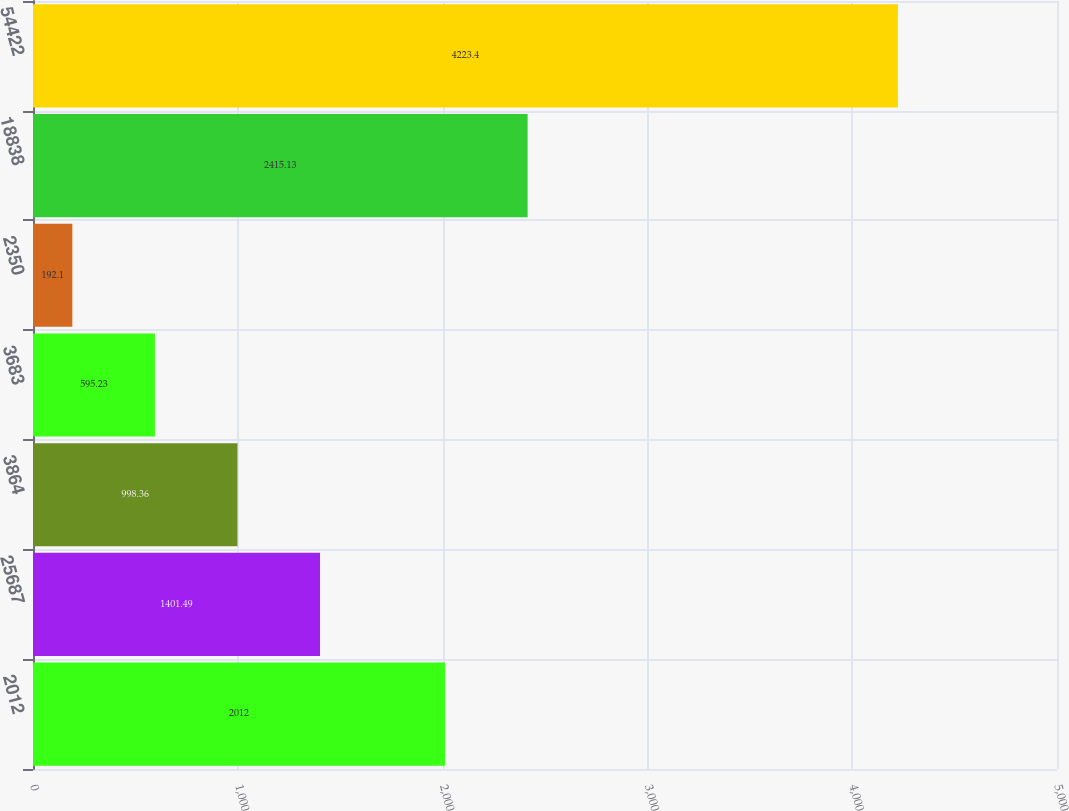Convert chart to OTSL. <chart><loc_0><loc_0><loc_500><loc_500><bar_chart><fcel>2012<fcel>25687<fcel>3864<fcel>3683<fcel>2350<fcel>18838<fcel>54422<nl><fcel>2012<fcel>1401.49<fcel>998.36<fcel>595.23<fcel>192.1<fcel>2415.13<fcel>4223.4<nl></chart> 